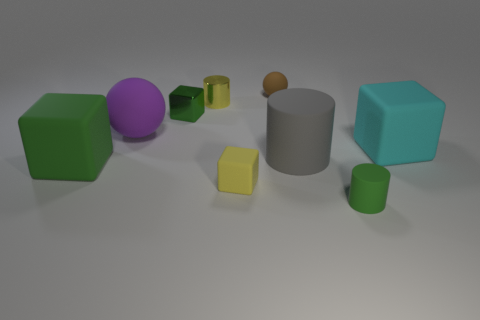Is there anything else that has the same material as the tiny yellow cylinder?
Provide a succinct answer. Yes. What is the small thing that is both in front of the small ball and to the right of the small yellow cube made of?
Give a very brief answer. Rubber. Do the small yellow matte object and the big purple thing have the same shape?
Ensure brevity in your answer.  No. There is a tiny yellow metal thing; how many tiny cylinders are to the right of it?
Your answer should be compact. 1. There is a shiny object on the right side of the green shiny block; is its size the same as the tiny brown rubber ball?
Keep it short and to the point. Yes. The big matte thing that is the same shape as the tiny green rubber object is what color?
Your response must be concise. Gray. There is a brown thing that is behind the tiny yellow cube; what is its shape?
Your answer should be compact. Sphere. How many other objects have the same shape as the cyan rubber object?
Your answer should be very brief. 3. There is a tiny cylinder on the left side of the big matte cylinder; does it have the same color as the small rubber thing that is on the left side of the tiny brown rubber ball?
Your answer should be very brief. Yes. How many things are either yellow shiny spheres or big gray rubber cylinders?
Your answer should be compact. 1. 